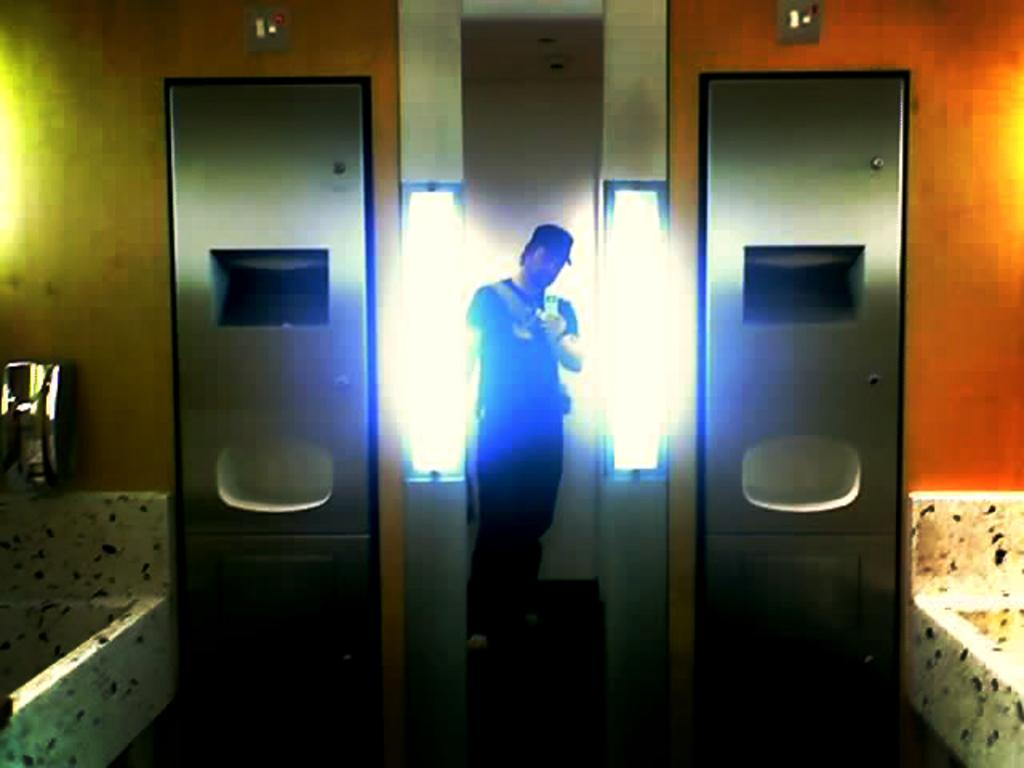Who is present in the image? There is a man in the image. What is the man wearing? The man is wearing a black dress. What is the man holding in his hand? The man is holding a camera in his hand. What can be seen on one side of the image? There is a bathtub on one side of the image. What can be seen on the other side of the image? There is a door-like object on the other side of the image. What type of peace symbol can be seen on the man's dress in the image? There is no peace symbol visible on the man's dress in the image. Can you describe the street where the man is taking photographs in the image? There is no street present in the image; it is an indoor setting with a bathtub and a door-like object. 